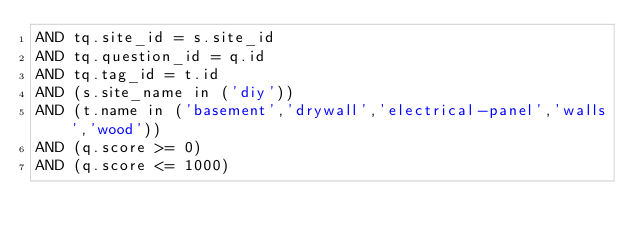<code> <loc_0><loc_0><loc_500><loc_500><_SQL_>AND tq.site_id = s.site_id
AND tq.question_id = q.id
AND tq.tag_id = t.id
AND (s.site_name in ('diy'))
AND (t.name in ('basement','drywall','electrical-panel','walls','wood'))
AND (q.score >= 0)
AND (q.score <= 1000)
</code> 